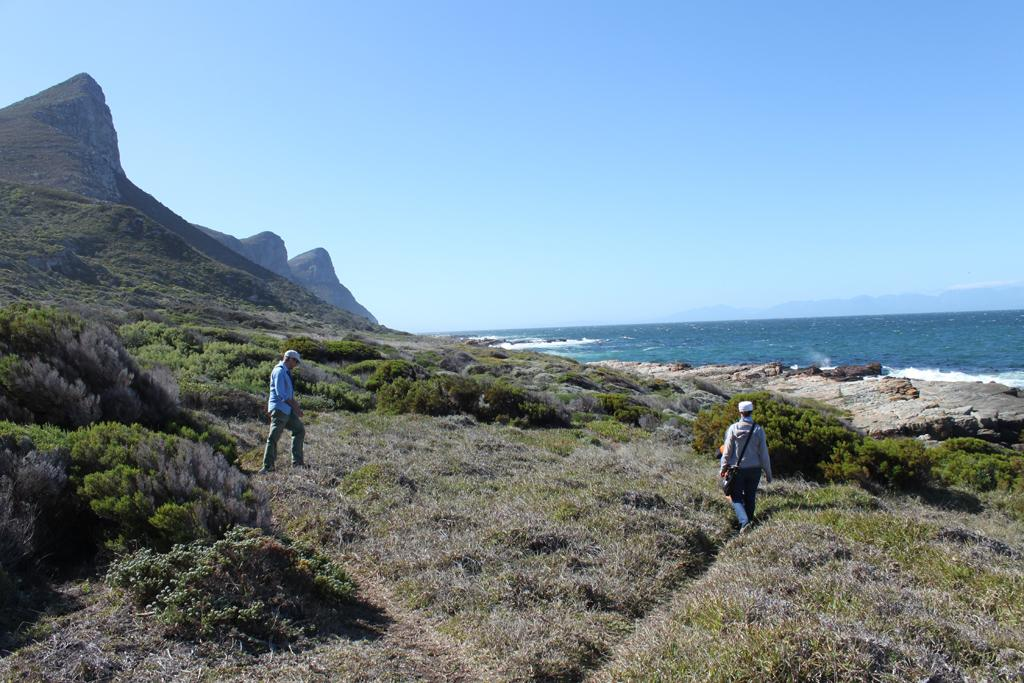What type of vegetation is present in the front of the image? There is dry grass in the front of the image. What are the people in the image doing? There are persons walking in the center of the image. What other natural elements can be seen in the image? There are plants in the image. What can be seen in the distance in the background of the image? There are mountains and an ocean in the background of the image. What type of cake is being served on the scarecrow in the image? There is no cake or scarecrow present in the image. What type of magic is being performed by the persons walking in the image? There is no magic or indication of any magical activity in the image. 